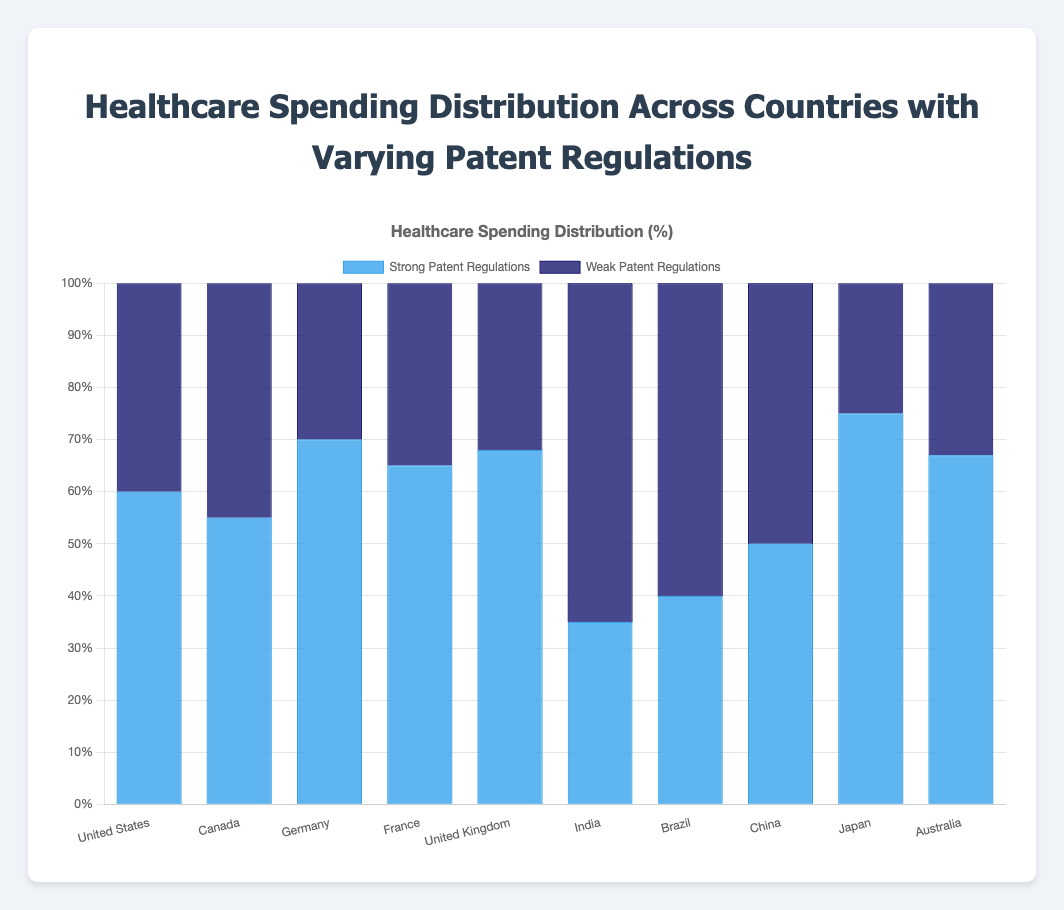What's the country with the highest percentage of healthcare spending under strong patent regulations? First, locate the highest blue bar which represents strong patent regulations. The highest bar corresponds to Japan with 75%.
Answer: Japan Which country has a higher percentage of healthcare spending under weak patent regulations: Brazil or India? Compare the dark blue bars for Brazil and India. Brazil's weak patent regulations bar is at 60% while India's is at 65%.
Answer: India What's the combined healthcare spending percentage under weak patent regulations for the United States and Canada? Add the percentages for weak patent regulations for the United States (40%) and Canada (45%): 40% + 45% = 85%
Answer: 85% How much more is the healthcare spending under strong patent regulations in Germany compared to China? Subtract the strong patent regulation percentage of China (50%) from Germany's (70%): 70% - 50% = 20%
Answer: 20% Which country has almost equal spending distribution between strong and weak patent regulations? Look for countries where the blue and dark blue bars are roughly the same height. China's bars are equal at 50%.
Answer: China By what percentage is Australia's healthcare spending higher under strong patent regulations compared to weak patent regulations? Subtract the weak patent regulation percentage (33%) from the strong one (67%): 67% - 33% = 34%
Answer: 34% What's the difference in healthcare spending under strong patent regulations between the country with the highest value and the country with the lowest value? Subtract the lowest value (India, 35%) from the highest value (Japan, 75%): 75% - 35% = 40%
Answer: 40% Which two countries have the same percentage of healthcare spending under strong patent regulations and weak patent regulations respectively? Identify countries with matching pairs of strong and weak percentages. France (strong: 65%, weak: 35%) and the United Kingdom (weak: 32%, strong: 68%) do not match. The United States (strong: 60%, weak: 40%) and Germany (strong: 70%, weak: 30%) also do not match in pairs. Thus, no two countries have matching percentages.
Answer: None What is the average healthcare spending distribution under strong patent regulations for France, Canada, and Australia? Add the strong patent regulation percentages for France (65%), Canada (55%), and Australia (67%) and divide by 3: (65% + 55% + 67%) / 3 = 62.33%
Answer: 62.33% 